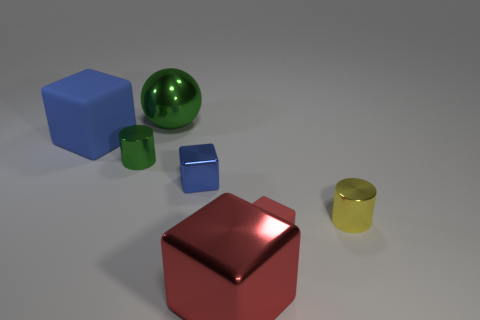How many rubber things are the same color as the big metal cube? There are two rubber objects that match the color of the large red metal cube - a small red cube and a red cylindrical rubber cap. 